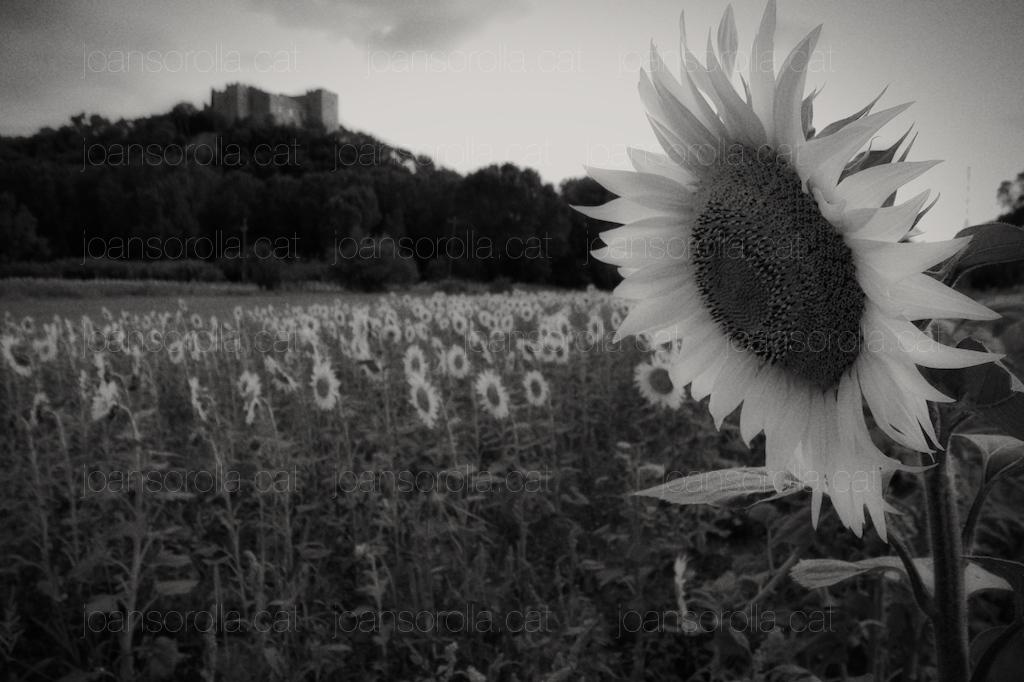What is the color scheme of the image? The image is black and white. What type of plants can be seen in the image? There are sunflowers and other plants in the image. What other natural elements are present in the image? There are trees in the image. What man-made structure is visible in the image? There is a building in the image. What part of the natural environment is visible in the image? The sky is visible in the image. What type of shirt is the sunflower wearing in the image? There are no sunflowers wearing shirts in the image, as sunflowers are plants and do not wear clothing. What is the iron used for in the image? There is no iron present in the image. 